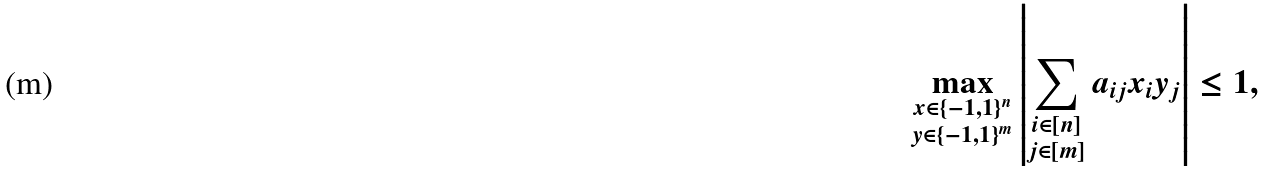<formula> <loc_0><loc_0><loc_500><loc_500>\max _ { \substack { x \in \{ - 1 , 1 \} ^ { n } \\ y \in \{ - 1 , 1 \} ^ { m } } } \left | \sum _ { \substack { i \in [ n ] \\ j \in [ m ] } } a _ { i j } x _ { i } y _ { j } \right | \leq 1 ,</formula> 